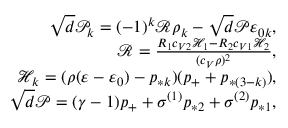Convert formula to latex. <formula><loc_0><loc_0><loc_500><loc_500>\begin{array} { r } { \sqrt { d } \mathcal { P } _ { k } = ( - 1 ) ^ { k } \mathcal { R } \rho _ { k } - \sqrt { d } \mathcal { P } \varepsilon _ { 0 k } , } \\ { \mathcal { R } = \frac { R _ { 1 } c _ { V 2 } \mathcal { H } _ { 1 } - R _ { 2 } c _ { V 1 } \mathcal { H } _ { 2 } } { ( c _ { V } \rho ) ^ { 2 } } , } \\ { \mathcal { H } _ { k } = ( \rho ( \varepsilon - \varepsilon _ { 0 } ) - p _ { * k } ) ( p _ { + } + p _ { * ( 3 - k ) } ) , } \\ { \sqrt { d } \mathcal { P } = ( \gamma - 1 ) p _ { + } + \sigma ^ { ( 1 ) } p _ { * 2 } + \sigma ^ { ( 2 ) } p _ { * 1 } , } \end{array}</formula> 